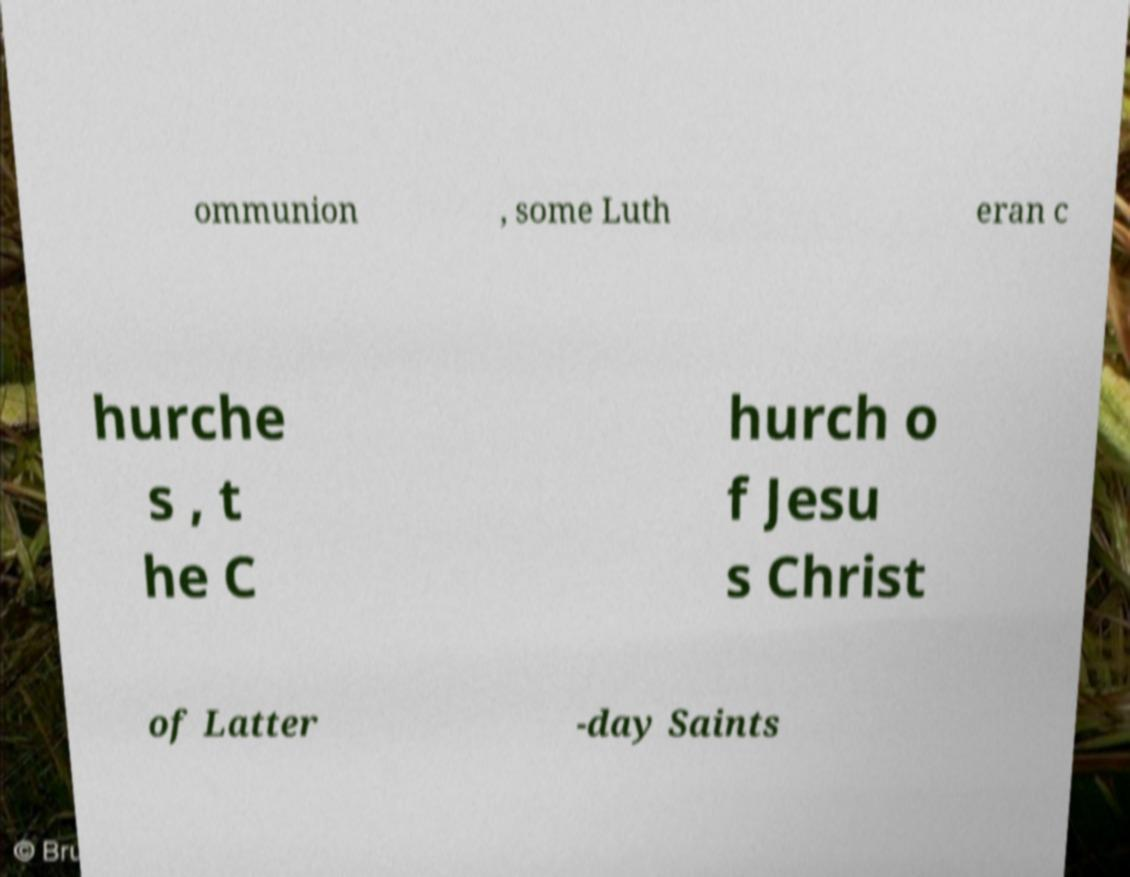Can you read and provide the text displayed in the image?This photo seems to have some interesting text. Can you extract and type it out for me? ommunion , some Luth eran c hurche s , t he C hurch o f Jesu s Christ of Latter -day Saints 